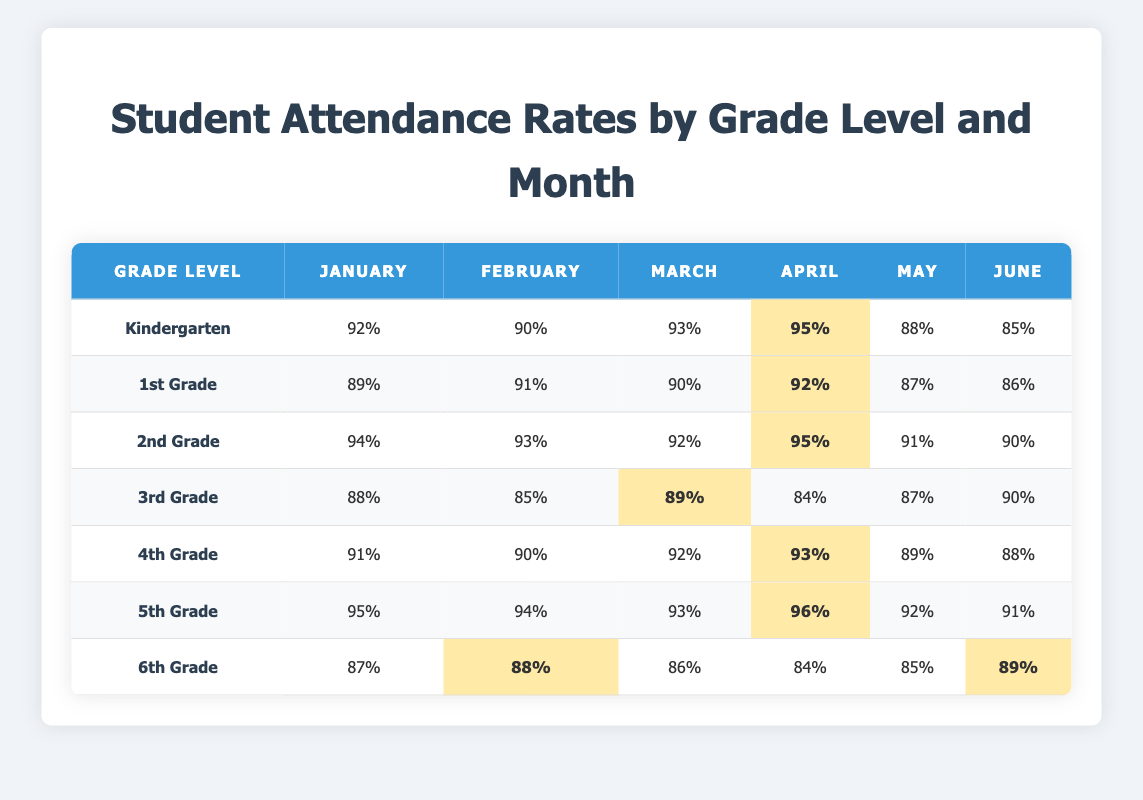What is the attendance rate for 5th Grade in April? The table shows that the attendance rate for 5th Grade in April is 96%.
Answer: 96% Which grade had the highest attendance rate in June? By reviewing the June column, we see that 6th Grade has the highest attendance rate at 89%.
Answer: 89% What is the average attendance rate for Kindergarten from January to June? To find the average, add all the attendance rates: 92 + 90 + 93 + 95 + 88 + 85 = 543, then divide by 6, so 543 / 6 = 90.5.
Answer: 90.5 Did 1st Grade have a higher attendance rate in February than in January? Yes, 1st Grade had an attendance rate of 91% in February, which is higher than 89% in January.
Answer: Yes What is the difference in attendance rates between 2nd Grade in January and 3rd Grade in March? 2nd Grade had an attendance rate of 94% in January, and 3rd Grade had 89% in March. The difference is 94 - 89 = 5%.
Answer: 5% Which grade level had a consistent increase in attendance rates from January to April? 5th Grade shows an increase from 95% in January to 96% in April without any decrease in between.
Answer: 5th Grade What was the overall trend in 6th Grade attendance rates from January to June? Analyzing the numbers, the rates decreased from January (87%) to April (84%) but then increased to 89% in June, indicating a slight recovery after a drop.
Answer: Decrease then recovery Which grade had the lowest attendance rate overall and what was that rate? Looking through each grade, 3rd Grade had the lowest overall attendance rate of 84% in April.
Answer: 84% How many grades had an attendance rate above 90% in May? In May, the following grades had above 90%: Kindergarten (88%), 2nd Grade (91%), 4th Grade (89%), and 5th Grade (92%). That makes four grades.
Answer: 4 grades What is the total attendance rate for 4th Grade from January to May? Adding the rates gives: 91 + 90 + 92 + 93 + 89 = 455. So, the total attendance rate for 4th Grade from January to May is 455%.
Answer: 455% Which month's attendance rate was the lowest for 3rd Grade? When looking at the 3rd Grade attendance rates, April shows the lowest rate at 84%.
Answer: 84% 